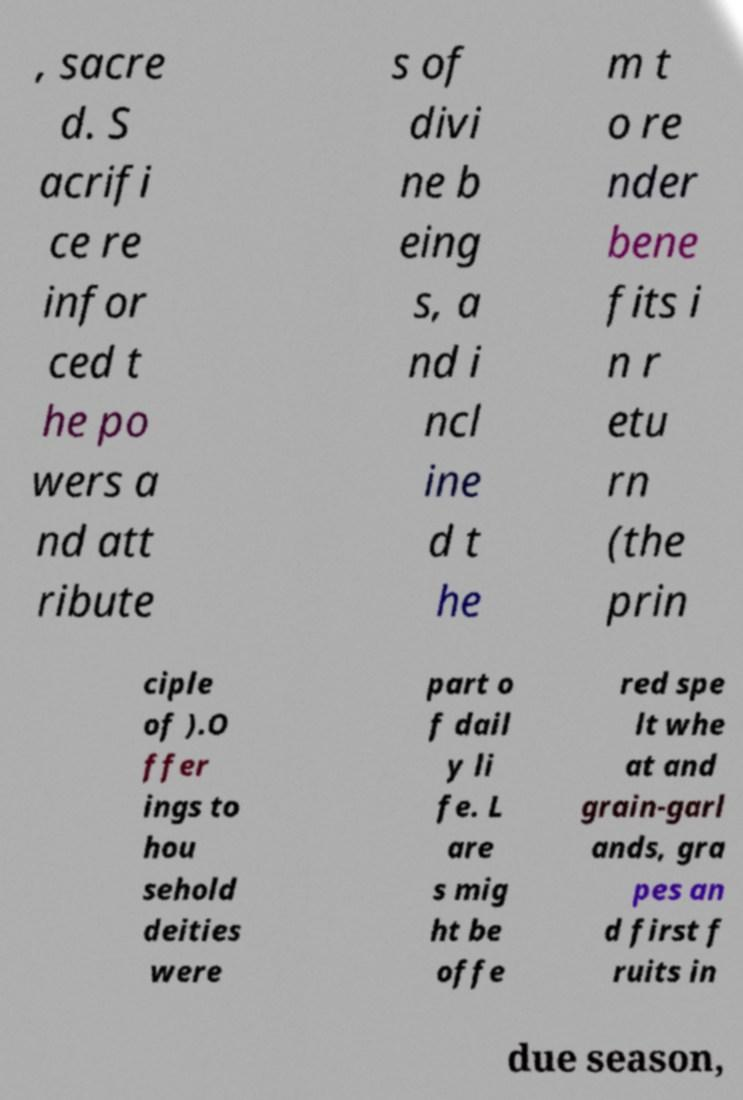Could you extract and type out the text from this image? , sacre d. S acrifi ce re infor ced t he po wers a nd att ribute s of divi ne b eing s, a nd i ncl ine d t he m t o re nder bene fits i n r etu rn (the prin ciple of ).O ffer ings to hou sehold deities were part o f dail y li fe. L are s mig ht be offe red spe lt whe at and grain-garl ands, gra pes an d first f ruits in due season, 